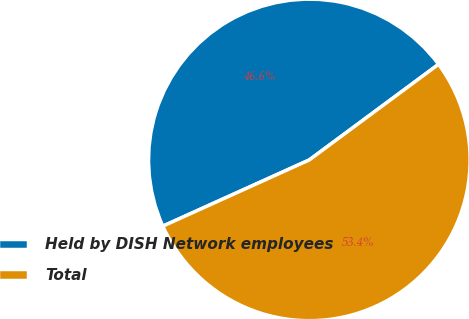Convert chart. <chart><loc_0><loc_0><loc_500><loc_500><pie_chart><fcel>Held by DISH Network employees<fcel>Total<nl><fcel>46.62%<fcel>53.38%<nl></chart> 